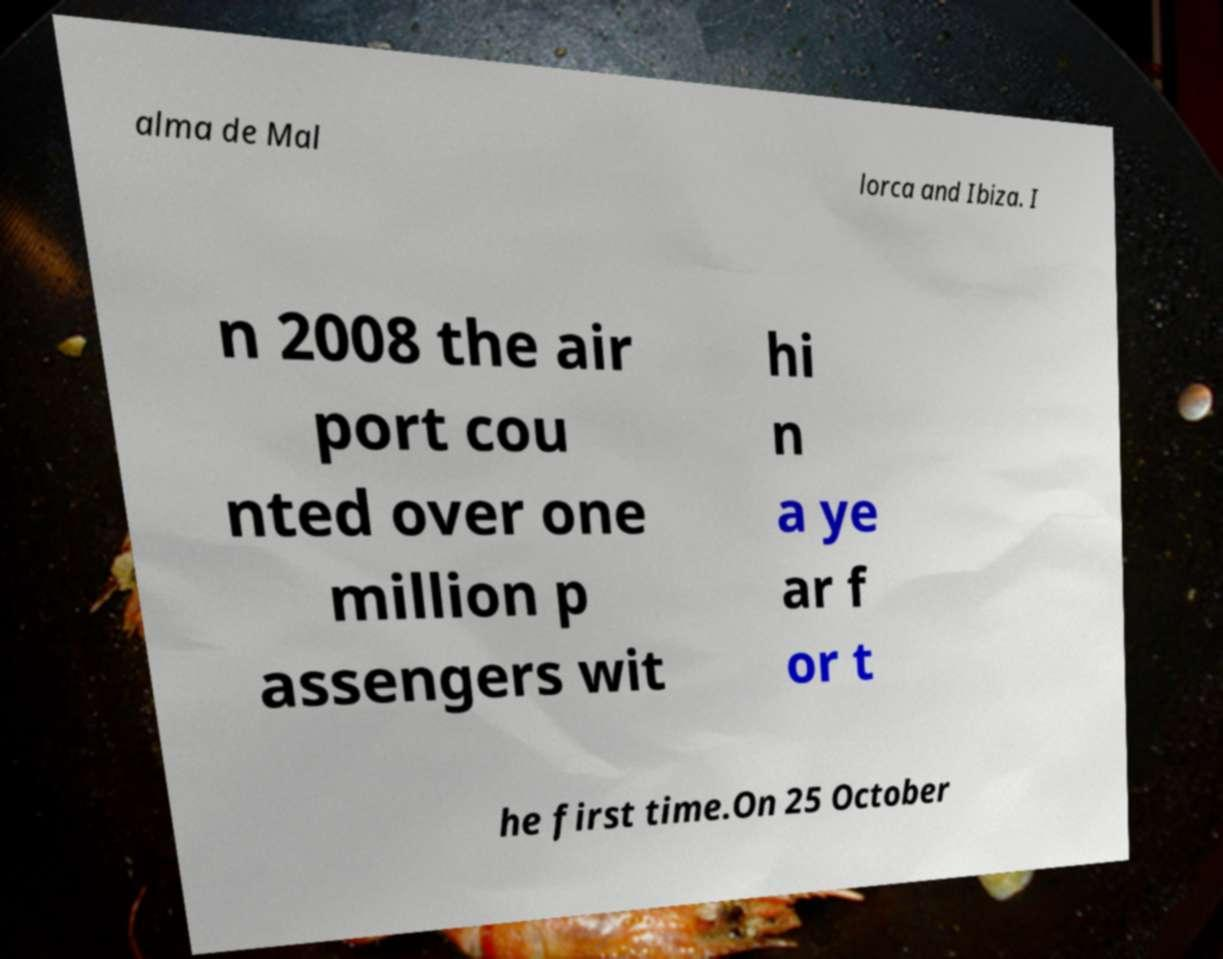Please read and relay the text visible in this image. What does it say? alma de Mal lorca and Ibiza. I n 2008 the air port cou nted over one million p assengers wit hi n a ye ar f or t he first time.On 25 October 